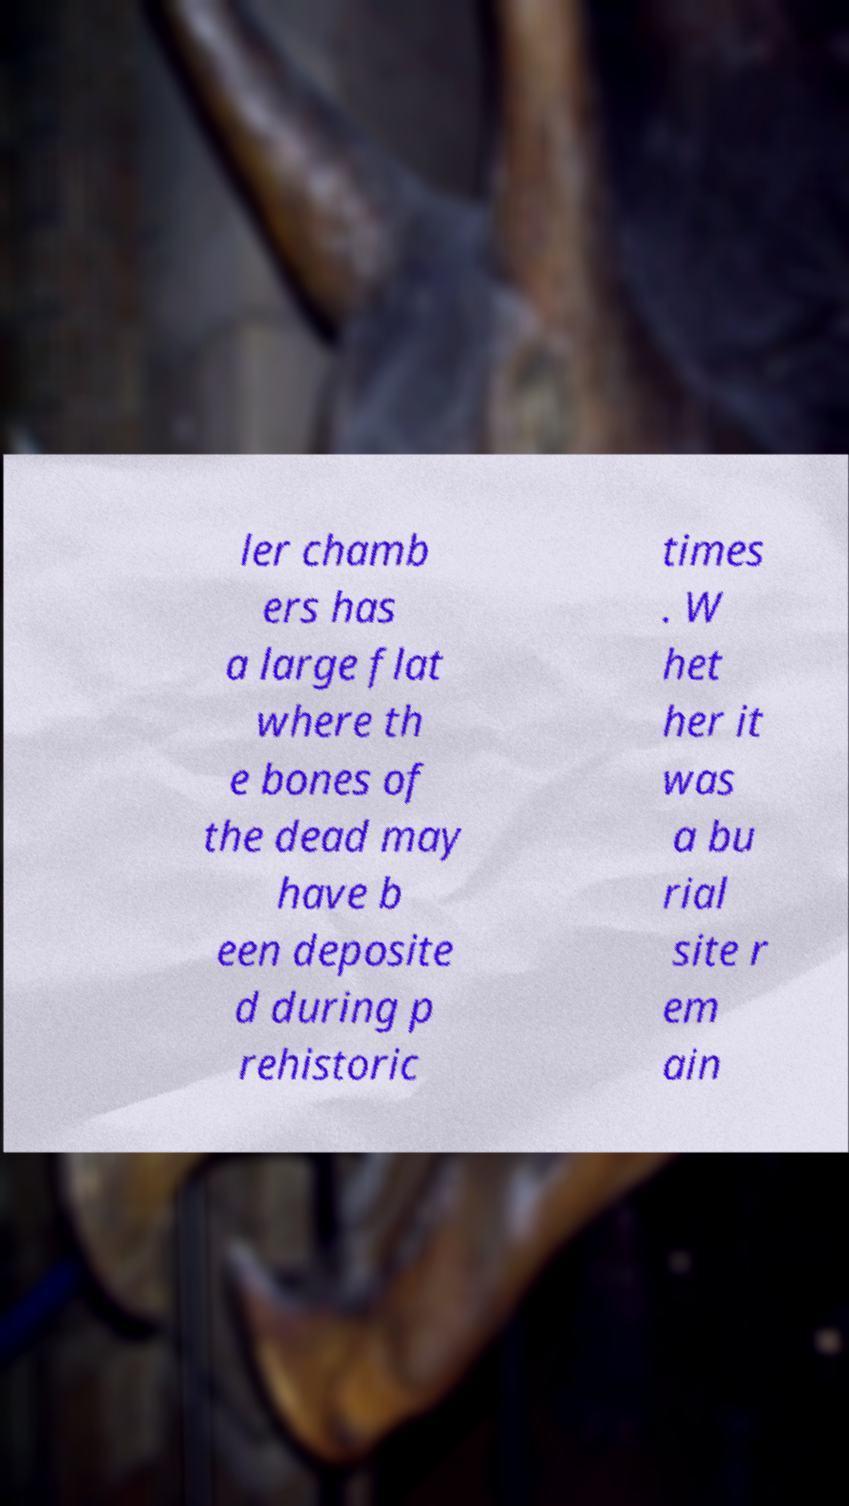Can you read and provide the text displayed in the image?This photo seems to have some interesting text. Can you extract and type it out for me? ler chamb ers has a large flat where th e bones of the dead may have b een deposite d during p rehistoric times . W het her it was a bu rial site r em ain 